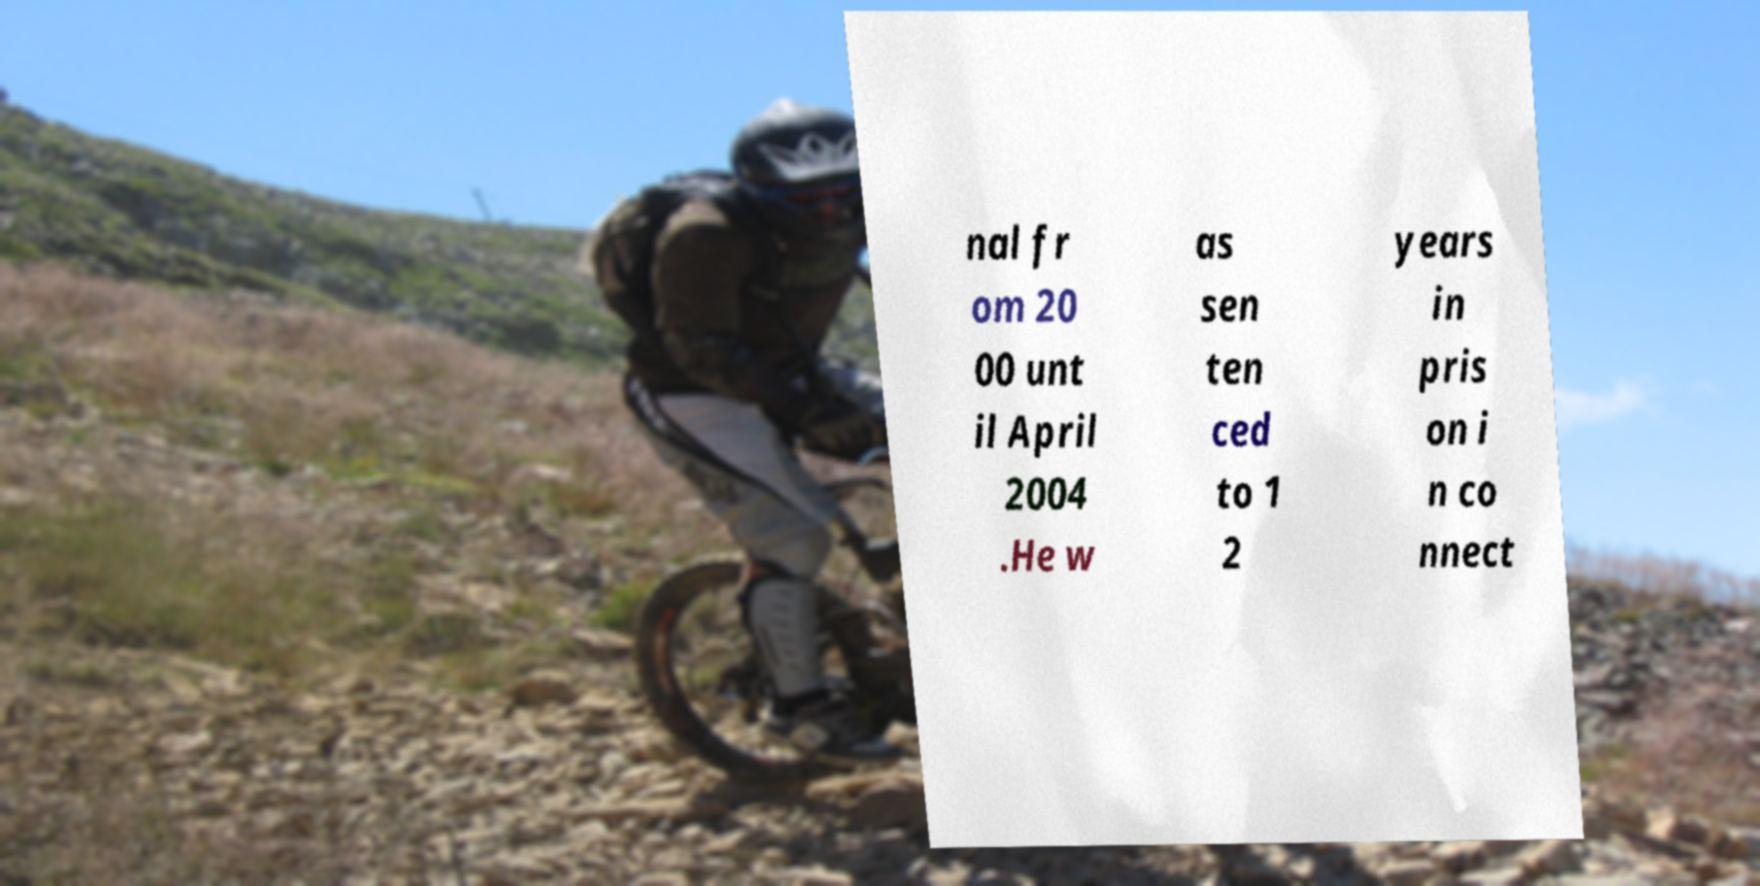What messages or text are displayed in this image? I need them in a readable, typed format. nal fr om 20 00 unt il April 2004 .He w as sen ten ced to 1 2 years in pris on i n co nnect 